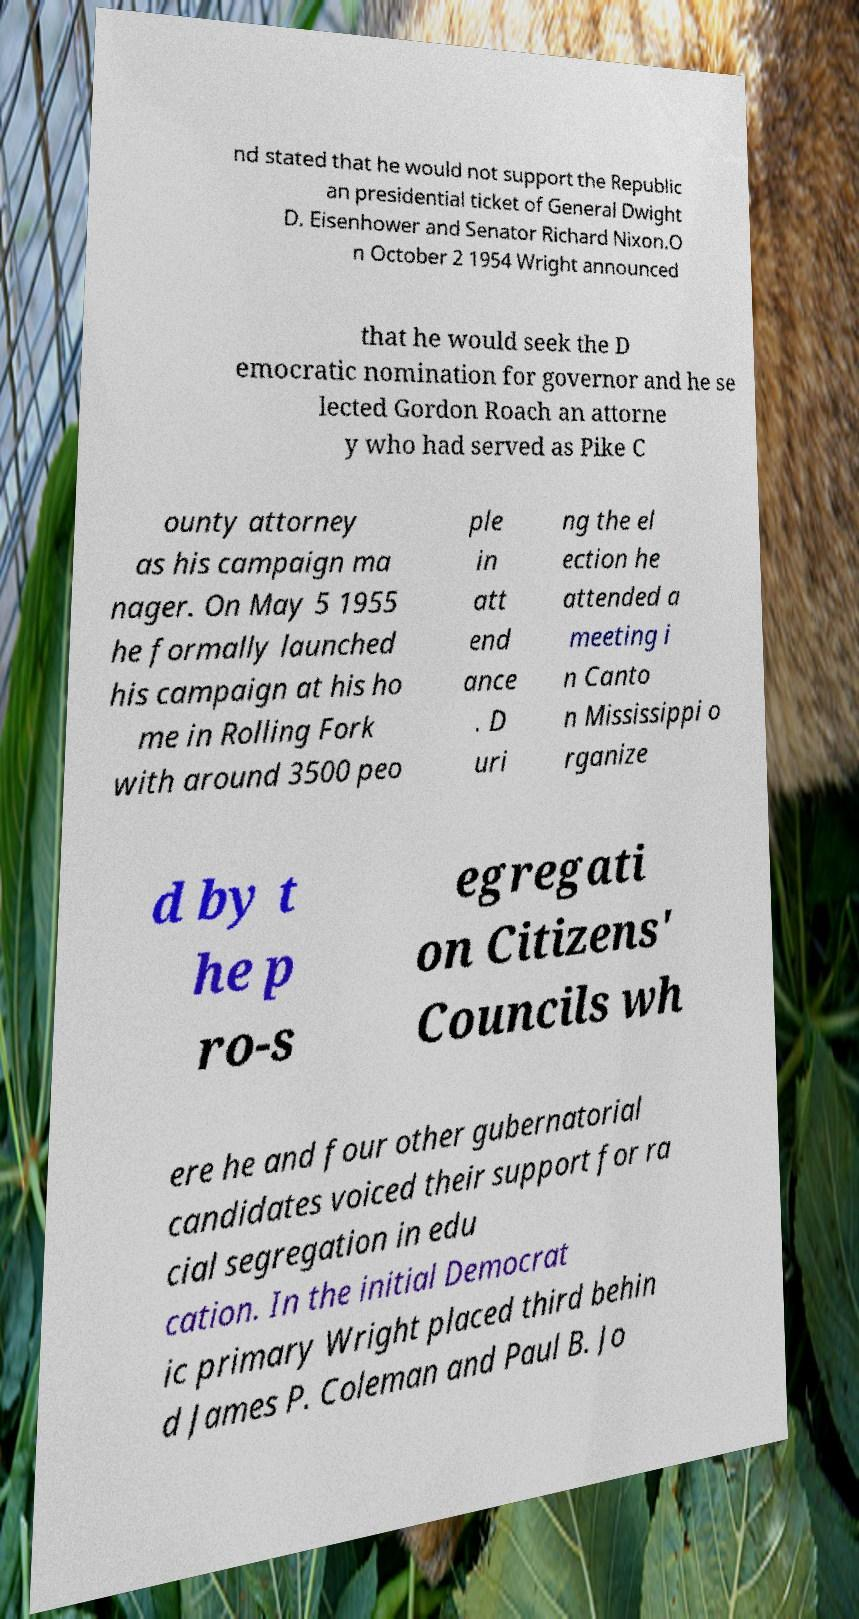Can you read and provide the text displayed in the image?This photo seems to have some interesting text. Can you extract and type it out for me? nd stated that he would not support the Republic an presidential ticket of General Dwight D. Eisenhower and Senator Richard Nixon.O n October 2 1954 Wright announced that he would seek the D emocratic nomination for governor and he se lected Gordon Roach an attorne y who had served as Pike C ounty attorney as his campaign ma nager. On May 5 1955 he formally launched his campaign at his ho me in Rolling Fork with around 3500 peo ple in att end ance . D uri ng the el ection he attended a meeting i n Canto n Mississippi o rganize d by t he p ro-s egregati on Citizens' Councils wh ere he and four other gubernatorial candidates voiced their support for ra cial segregation in edu cation. In the initial Democrat ic primary Wright placed third behin d James P. Coleman and Paul B. Jo 